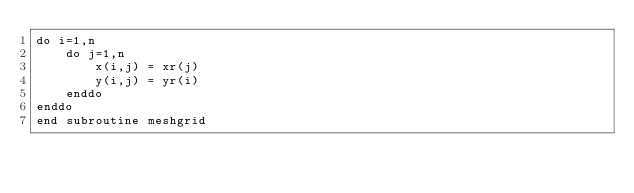Convert code to text. <code><loc_0><loc_0><loc_500><loc_500><_FORTRAN_>do i=1,n
    do j=1,n
        x(i,j) = xr(j)
        y(i,j) = yr(i)
    enddo
enddo
end subroutine meshgrid</code> 